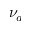<formula> <loc_0><loc_0><loc_500><loc_500>\nu _ { a }</formula> 